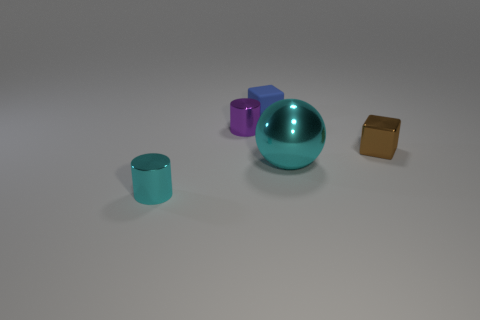Subtract all blue blocks. How many blocks are left? 1 Subtract 1 blocks. How many blocks are left? 1 Add 4 purple objects. How many objects exist? 9 Subtract all cylinders. How many objects are left? 3 Subtract all gray cylinders. Subtract all red spheres. How many cylinders are left? 2 Subtract all metal cylinders. Subtract all small brown blocks. How many objects are left? 2 Add 1 cyan balls. How many cyan balls are left? 2 Add 3 yellow rubber things. How many yellow rubber things exist? 3 Subtract 0 red cylinders. How many objects are left? 5 